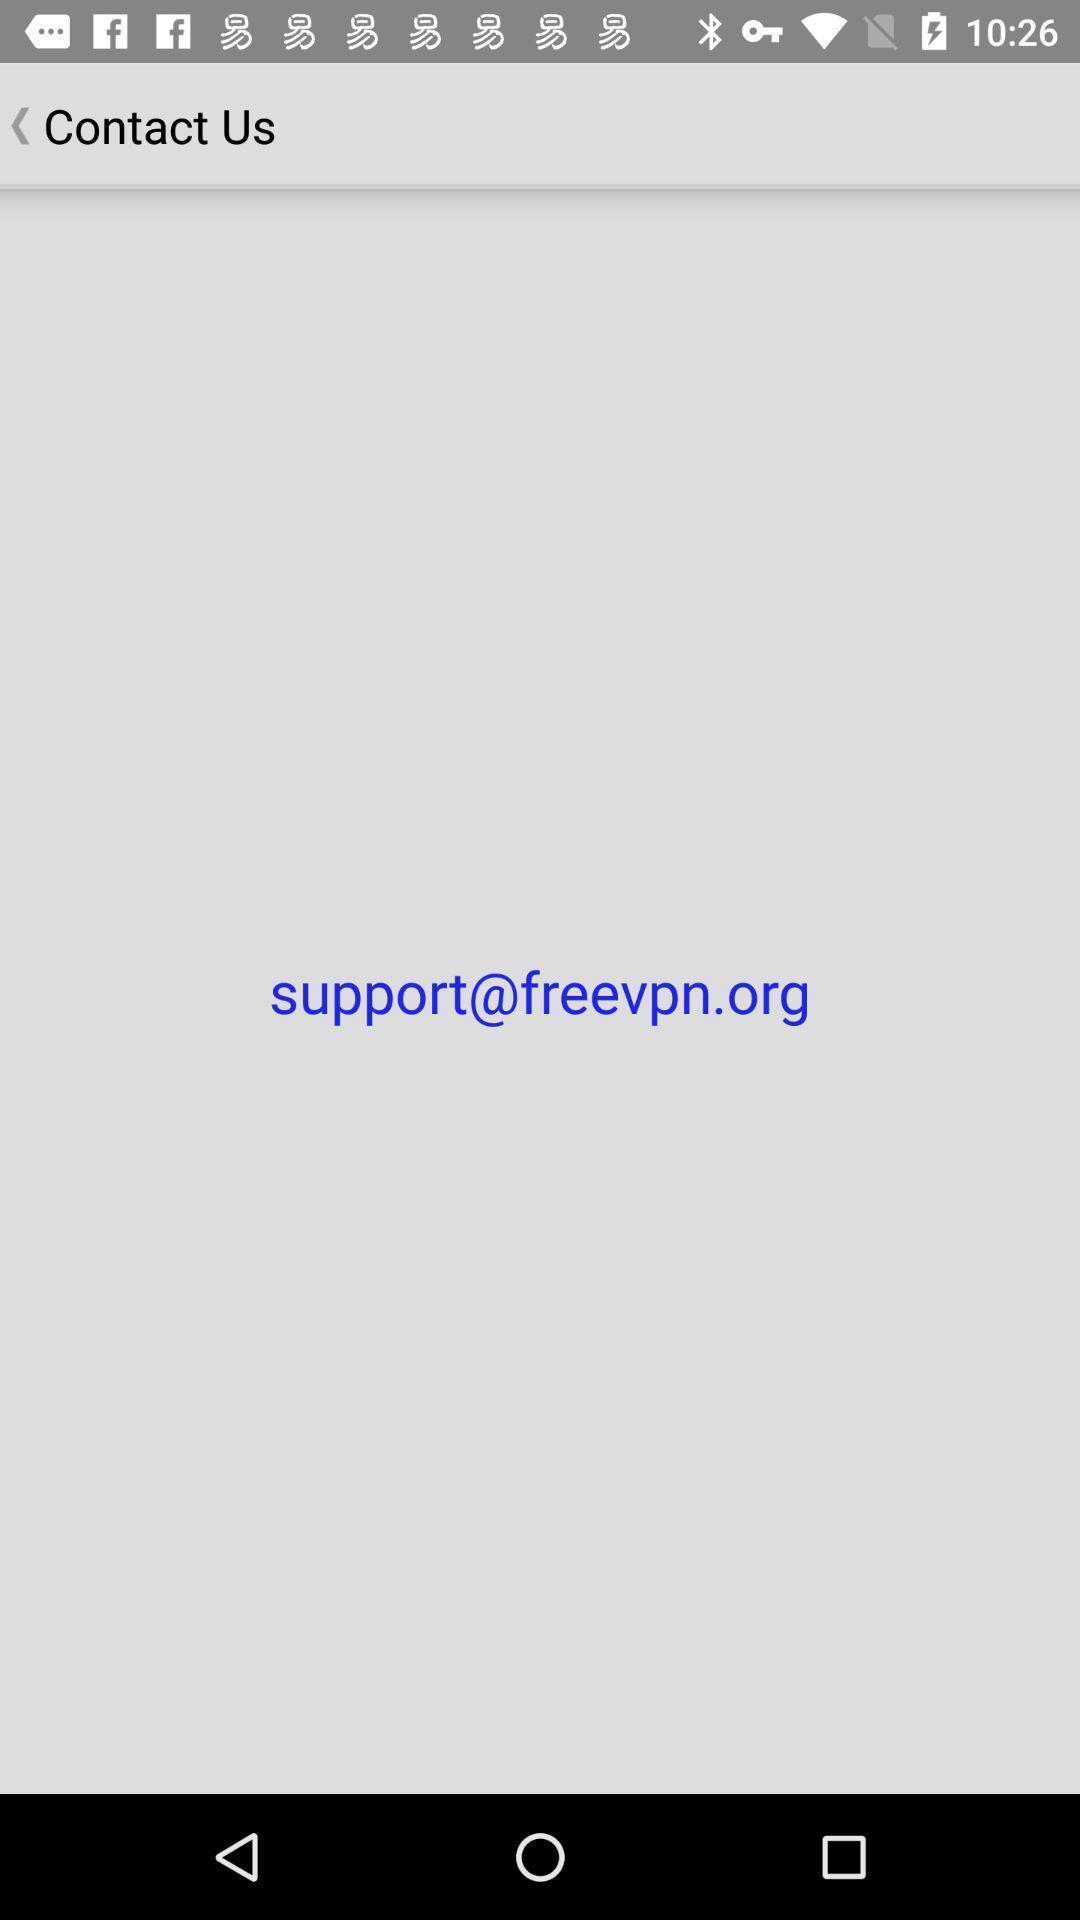Give me a summary of this screen capture. Page to contact the support. 